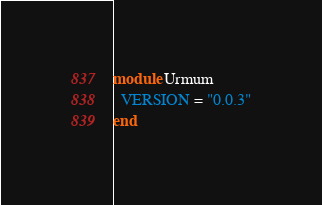Convert code to text. <code><loc_0><loc_0><loc_500><loc_500><_Ruby_>module Urmum
  VERSION = "0.0.3"
end
</code> 